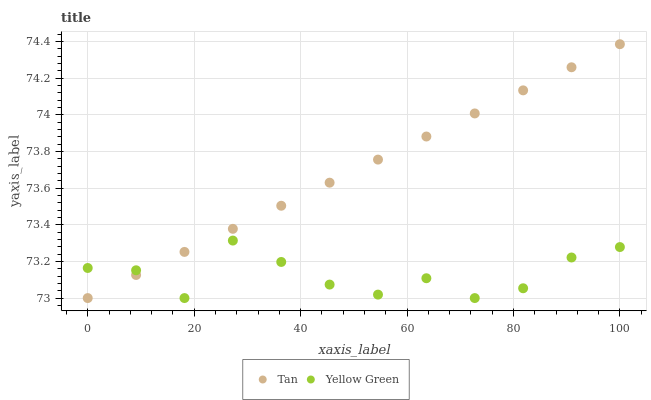Does Yellow Green have the minimum area under the curve?
Answer yes or no. Yes. Does Tan have the maximum area under the curve?
Answer yes or no. Yes. Does Yellow Green have the maximum area under the curve?
Answer yes or no. No. Is Tan the smoothest?
Answer yes or no. Yes. Is Yellow Green the roughest?
Answer yes or no. Yes. Is Yellow Green the smoothest?
Answer yes or no. No. Does Tan have the lowest value?
Answer yes or no. Yes. Does Tan have the highest value?
Answer yes or no. Yes. Does Yellow Green have the highest value?
Answer yes or no. No. Does Yellow Green intersect Tan?
Answer yes or no. Yes. Is Yellow Green less than Tan?
Answer yes or no. No. Is Yellow Green greater than Tan?
Answer yes or no. No. 